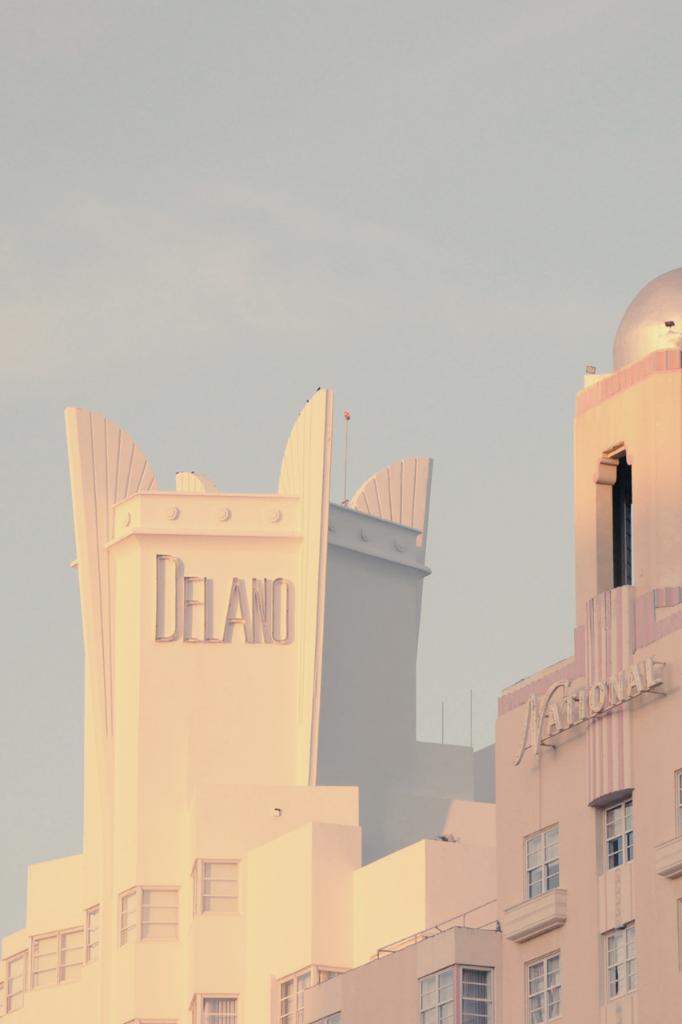How would you summarize this image in a sentence or two? In this image we can see a building with windows. Also there are names on the building. In the background there is sky. 